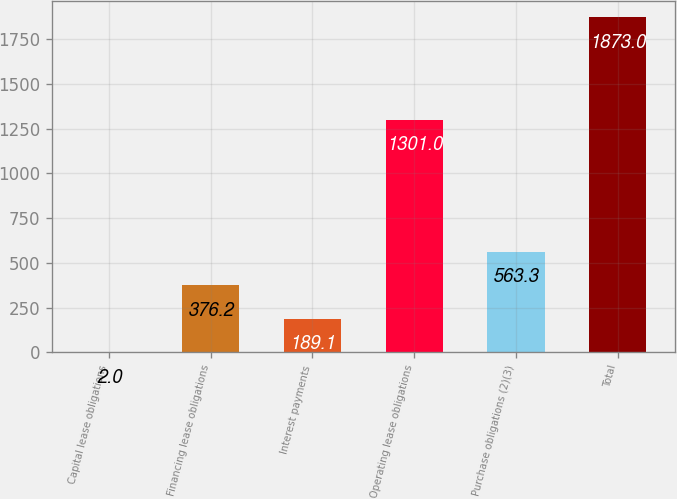Convert chart to OTSL. <chart><loc_0><loc_0><loc_500><loc_500><bar_chart><fcel>Capital lease obligations<fcel>Financing lease obligations<fcel>Interest payments<fcel>Operating lease obligations<fcel>Purchase obligations (2)(3)<fcel>Total<nl><fcel>2<fcel>376.2<fcel>189.1<fcel>1301<fcel>563.3<fcel>1873<nl></chart> 